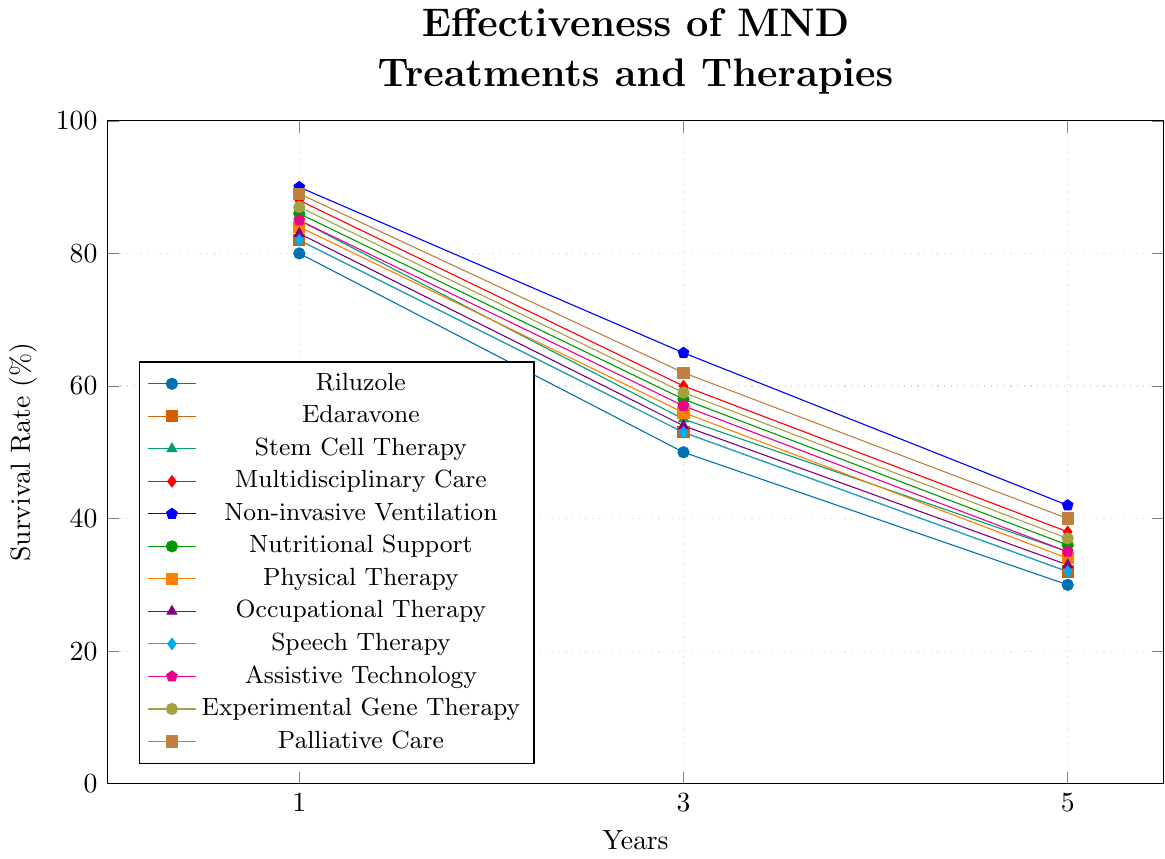Which treatment has the highest 1-year survival rate? Looking at the 1-year data points, the highest value is 90% for Non-invasive Ventilation
Answer: Non-invasive Ventilation How does the 3-year survival rate of Physical Therapy compare to that of Nutritional Support? The 3-year survival rate for Physical Therapy is 56%, and for Nutritional Support, it is 58%. Comparing the two, Physical Therapy has a lower rate.
Answer: Physical Therapy is lower What's the average 5-year survival rate for Edaravone, Stem Cell Therapy, and Nutritional Support? Edaravone has a 5-year survival rate of 32%, Stem Cell Therapy 35%, and Nutritional Support 36%. Average = (32+35+36)/3 = 33
Answer: 33 Which two treatments have the same 1-year survival rate and what is that rate? Both Edaravone and Speech Therapy have a 1-year survival rate of 82%
Answer: Edaravone and Speech Therapy, 82% What is the percentage decrease in survival rate from 1 year to 5 years for Palliative Care? Palliative Care: 1-year is 89%, 5-year is 40%. Percentage decrease = ((89-40)/89) * 100 = 55.06%
Answer: 55.06% How many treatments have a 5-year survival rate of 35% or higher? Treatments: Stem Cell Therapy (35%), Multidisciplinary Care (38%), Non-invasive Ventilation (42%), Nutritional Support (36%), and Assistive Technology (35%). Five treatments meet the criteria.
Answer: Five Which treatment experiences the largest drop in survival rate from 1 year to 5 years? Calculate the differences: Riluzole (50%), Edaravone (50%), Stem Cell Therapy (50%), etc. The largest difference is for Riluzole with a drop of 50%.
Answer: Riluzole Are there any treatments that have identical survival rates at each of the three time points? Looking at the plots, Edaravone and Speech Therapy have identical survival rates: 82% (1-year), 53% (3-year), and 32% (5-year)
Answer: Edaravone and Speech Therapy What is the median 3-year survival rate among all treatments? 3-year rates: 50, 53, 53, 54, 55, 56, 57, 58, 59, 60, 62, 65. Median (ordered list) = (56+57)/2 = 56.5
Answer: 56.5 